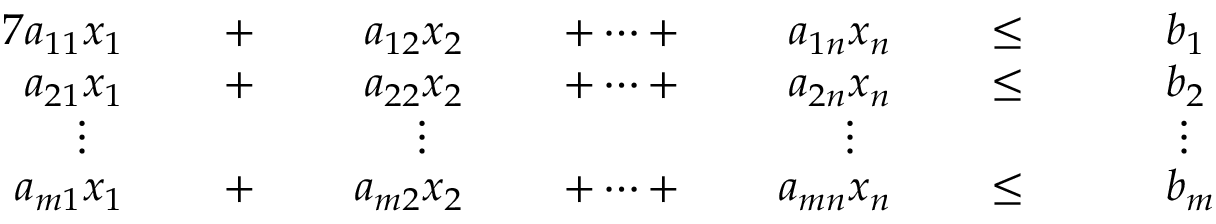Convert formula to latex. <formula><loc_0><loc_0><loc_500><loc_500>{ \begin{array} { r l r l r l r l r l r l r l } { { 7 } a _ { 1 1 } x _ { 1 } } & { \, + \, } & { a _ { 1 2 } x _ { 2 } } & { \, + \cdots + \, } & { a _ { 1 n } x _ { n } } & { \, \leq \, } & & { b _ { 1 } } \\ { a _ { 2 1 } x _ { 1 } } & { \, + \, } & { a _ { 2 2 } x _ { 2 } } & { \, + \cdots + \, } & { a _ { 2 n } x _ { n } } & { \, \leq \, } & & { b _ { 2 } } \\ { \vdots \, } & & { \vdots \, } & & { \vdots \, } & & & { \, \vdots } \\ { a _ { m 1 } x _ { 1 } } & { \, + \, } & { a _ { m 2 } x _ { 2 } } & { \, + \cdots + \, } & { a _ { m n } x _ { n } } & { \, \leq \, } & & { b _ { m } } \end{array} }</formula> 